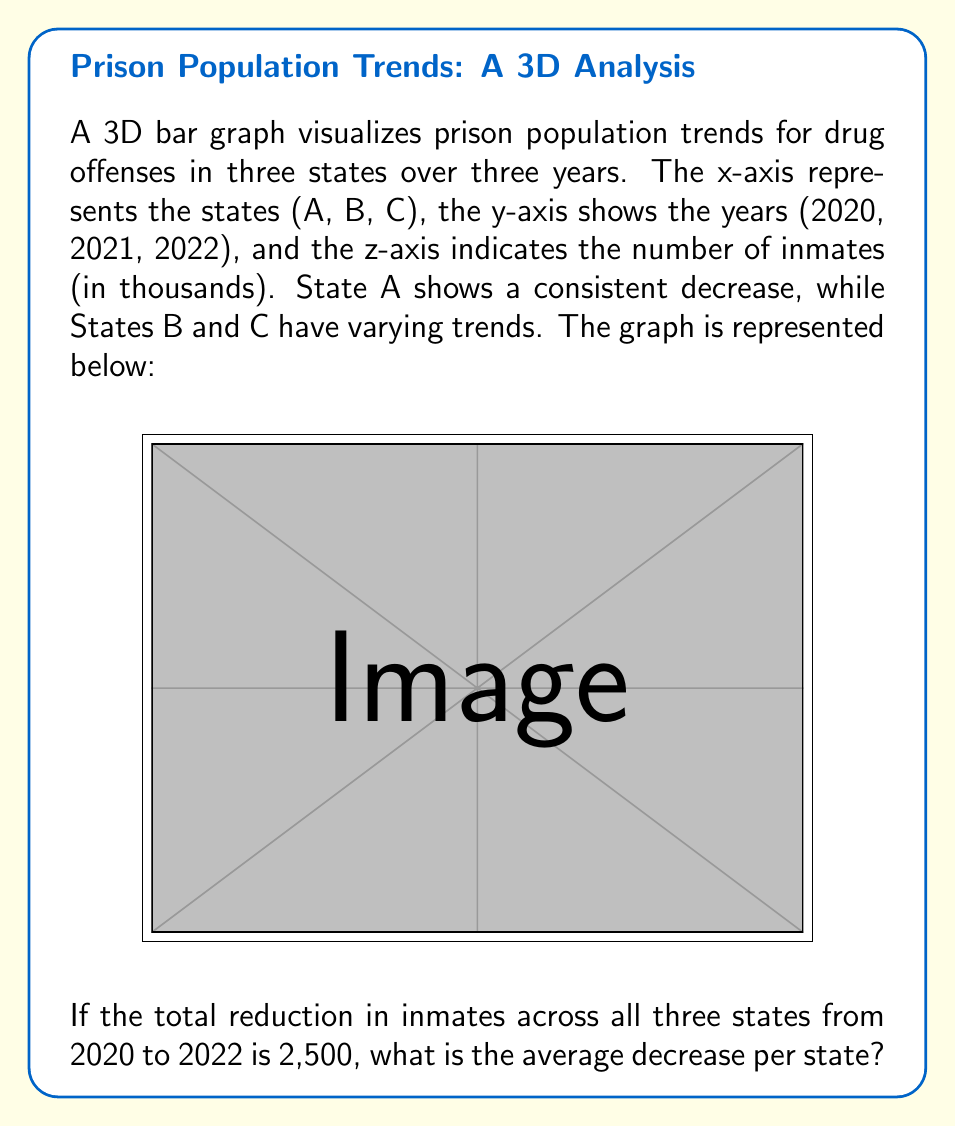Can you answer this question? To solve this problem, let's follow these steps:

1) First, we need to understand what the question is asking. We're looking for the average decrease per state from 2020 to 2022.

2) We're given that the total reduction across all three states is 2,500 inmates.

3) To find the average decrease per state, we need to divide the total reduction by the number of states:

   $$\text{Average decrease} = \frac{\text{Total reduction}}{\text{Number of states}}$$

4) We know:
   - Total reduction = 2,500 inmates
   - Number of states = 3

5) Let's plug these values into our equation:

   $$\text{Average decrease} = \frac{2,500}{3}$$

6) Calculating this:
   
   $$\text{Average decrease} = 833.33 \text{ (rounded to two decimal places)}$$

7) Since we're dealing with people, we should round down to the nearest whole number:

   $$\text{Average decrease} = 833 \text{ inmates}$$

This means that, on average, each state decreased its inmate population for drug offenses by 833 people from 2020 to 2022.
Answer: 833 inmates 